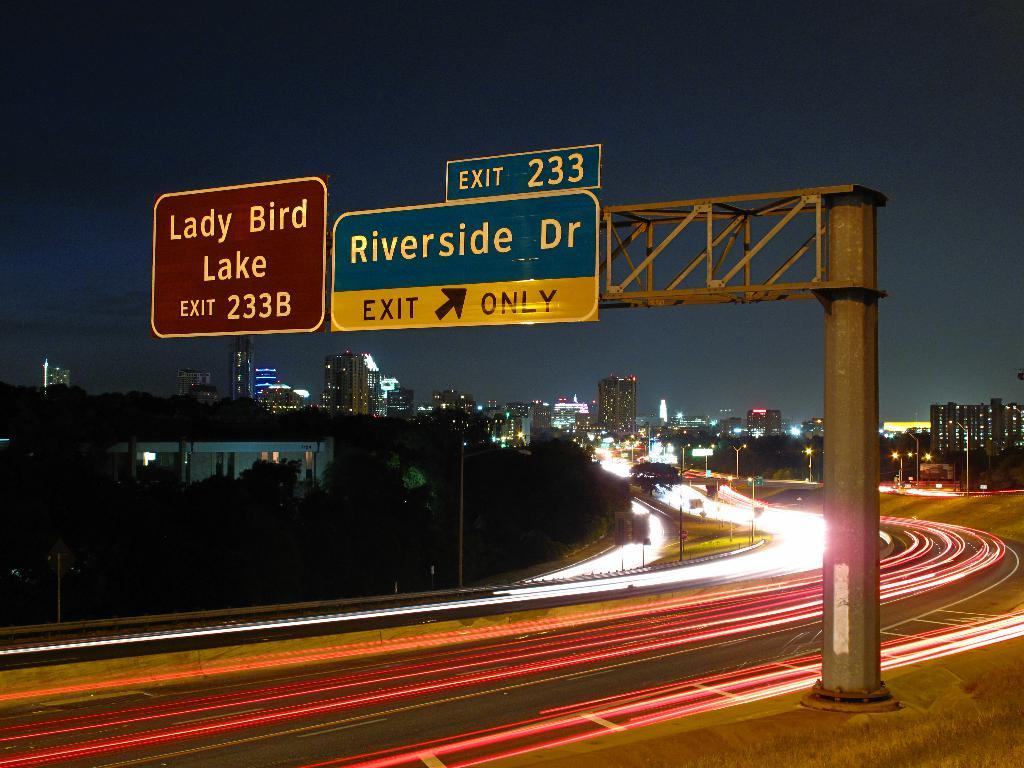<image>
Relay a brief, clear account of the picture shown. a sign that says riverside at the top 